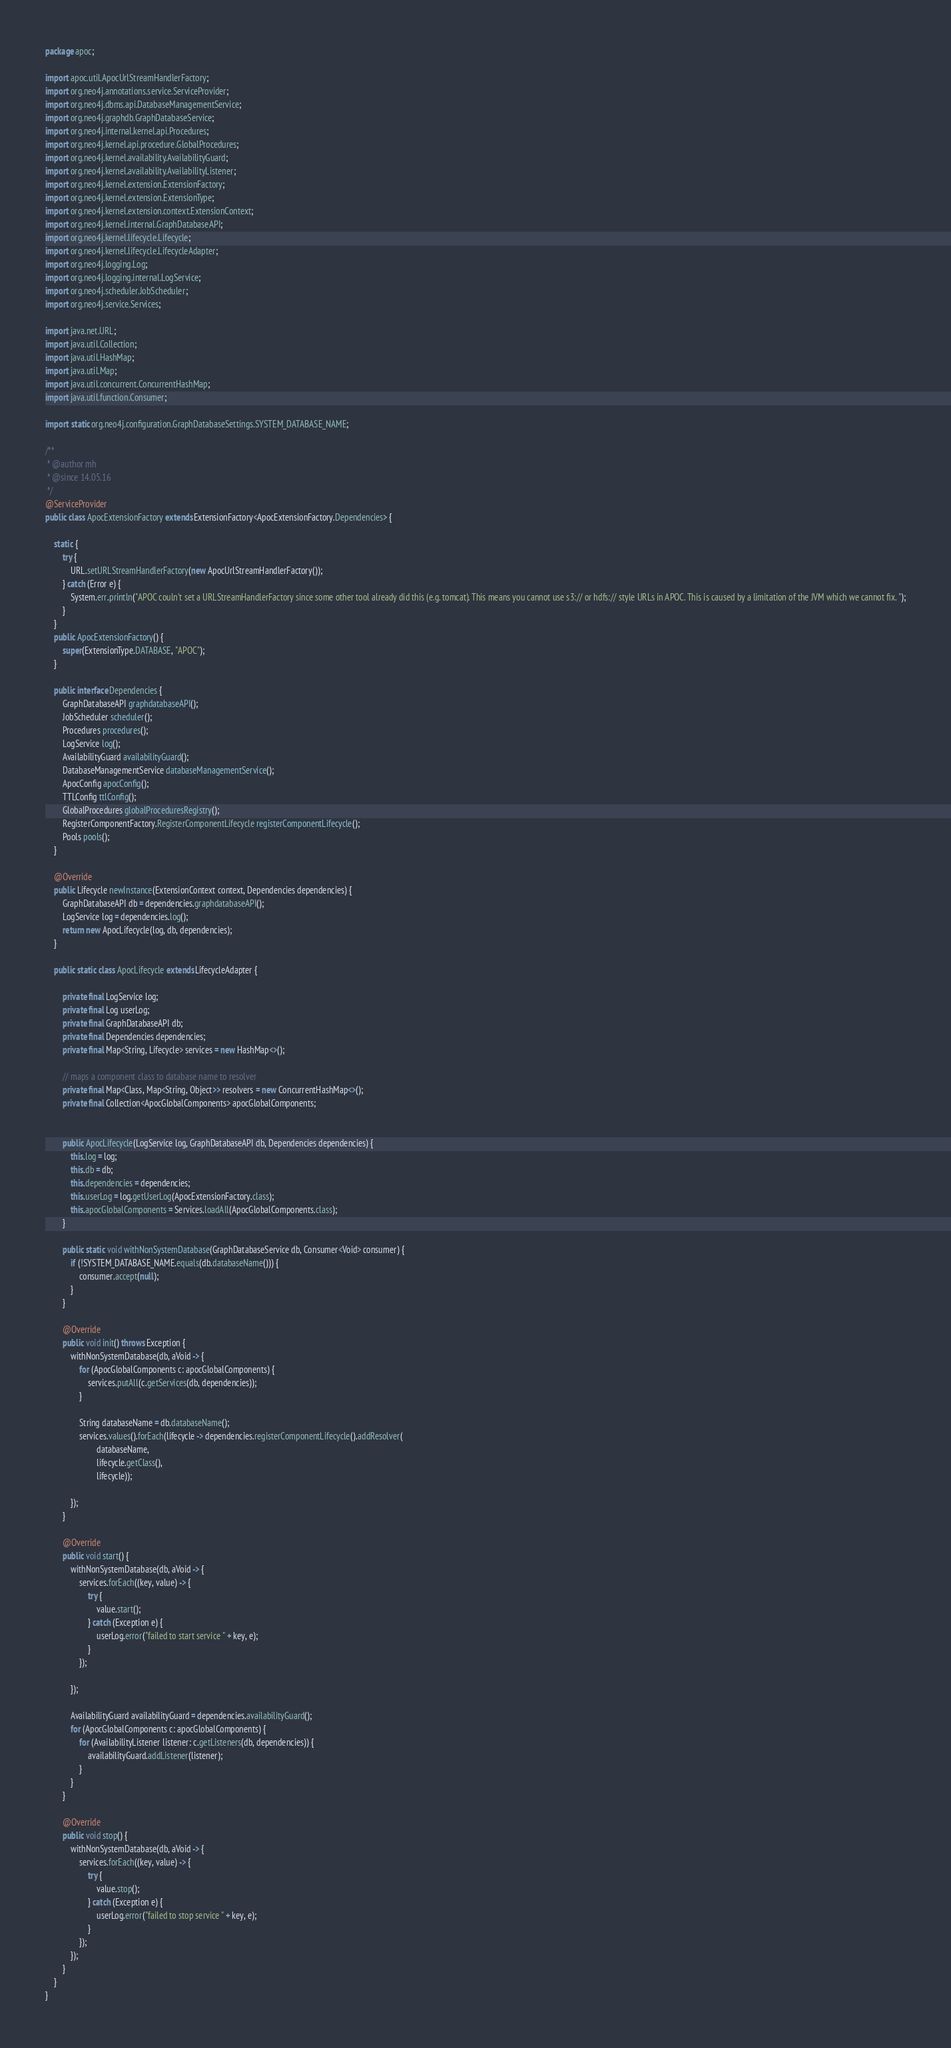Convert code to text. <code><loc_0><loc_0><loc_500><loc_500><_Java_>package apoc;

import apoc.util.ApocUrlStreamHandlerFactory;
import org.neo4j.annotations.service.ServiceProvider;
import org.neo4j.dbms.api.DatabaseManagementService;
import org.neo4j.graphdb.GraphDatabaseService;
import org.neo4j.internal.kernel.api.Procedures;
import org.neo4j.kernel.api.procedure.GlobalProcedures;
import org.neo4j.kernel.availability.AvailabilityGuard;
import org.neo4j.kernel.availability.AvailabilityListener;
import org.neo4j.kernel.extension.ExtensionFactory;
import org.neo4j.kernel.extension.ExtensionType;
import org.neo4j.kernel.extension.context.ExtensionContext;
import org.neo4j.kernel.internal.GraphDatabaseAPI;
import org.neo4j.kernel.lifecycle.Lifecycle;
import org.neo4j.kernel.lifecycle.LifecycleAdapter;
import org.neo4j.logging.Log;
import org.neo4j.logging.internal.LogService;
import org.neo4j.scheduler.JobScheduler;
import org.neo4j.service.Services;

import java.net.URL;
import java.util.Collection;
import java.util.HashMap;
import java.util.Map;
import java.util.concurrent.ConcurrentHashMap;
import java.util.function.Consumer;

import static org.neo4j.configuration.GraphDatabaseSettings.SYSTEM_DATABASE_NAME;

/**
 * @author mh
 * @since 14.05.16
 */
@ServiceProvider
public class ApocExtensionFactory extends ExtensionFactory<ApocExtensionFactory.Dependencies> {

    static {
        try {
            URL.setURLStreamHandlerFactory(new ApocUrlStreamHandlerFactory());
        } catch (Error e) {
            System.err.println("APOC couln't set a URLStreamHandlerFactory since some other tool already did this (e.g. tomcat). This means you cannot use s3:// or hdfs:// style URLs in APOC. This is caused by a limitation of the JVM which we cannot fix. ");
        }
    }
    public ApocExtensionFactory() {
        super(ExtensionType.DATABASE, "APOC");
    }

    public interface Dependencies {
        GraphDatabaseAPI graphdatabaseAPI();
        JobScheduler scheduler();
        Procedures procedures();
        LogService log();
        AvailabilityGuard availabilityGuard();
        DatabaseManagementService databaseManagementService();
        ApocConfig apocConfig();
        TTLConfig ttlConfig();
        GlobalProcedures globalProceduresRegistry();
        RegisterComponentFactory.RegisterComponentLifecycle registerComponentLifecycle();
        Pools pools();
    }

    @Override
    public Lifecycle newInstance(ExtensionContext context, Dependencies dependencies) {
        GraphDatabaseAPI db = dependencies.graphdatabaseAPI();
        LogService log = dependencies.log();
        return new ApocLifecycle(log, db, dependencies);
    }

    public static class ApocLifecycle extends LifecycleAdapter {

        private final LogService log;
        private final Log userLog;
        private final GraphDatabaseAPI db;
        private final Dependencies dependencies;
        private final Map<String, Lifecycle> services = new HashMap<>();

        // maps a component class to database name to resolver
        private final Map<Class, Map<String, Object>> resolvers = new ConcurrentHashMap<>();
        private final Collection<ApocGlobalComponents> apocGlobalComponents;


        public ApocLifecycle(LogService log, GraphDatabaseAPI db, Dependencies dependencies) {
            this.log = log;
            this.db = db;
            this.dependencies = dependencies;
            this.userLog = log.getUserLog(ApocExtensionFactory.class);
            this.apocGlobalComponents = Services.loadAll(ApocGlobalComponents.class);
        }

        public static void withNonSystemDatabase(GraphDatabaseService db, Consumer<Void> consumer) {
            if (!SYSTEM_DATABASE_NAME.equals(db.databaseName())) {
                consumer.accept(null);
            }
        }

        @Override
        public void init() throws Exception {
            withNonSystemDatabase(db, aVoid -> {
                for (ApocGlobalComponents c: apocGlobalComponents) {
                    services.putAll(c.getServices(db, dependencies));
                }

                String databaseName = db.databaseName();
                services.values().forEach(lifecycle -> dependencies.registerComponentLifecycle().addResolver(
                        databaseName,
                        lifecycle.getClass(),
                        lifecycle));

            });
        }

        @Override
        public void start() {
            withNonSystemDatabase(db, aVoid -> {
                services.forEach((key, value) -> {
                    try {
                        value.start();
                    } catch (Exception e) {
                        userLog.error("failed to start service " + key, e);
                    }
                });

            });

            AvailabilityGuard availabilityGuard = dependencies.availabilityGuard();
            for (ApocGlobalComponents c: apocGlobalComponents) {
                for (AvailabilityListener listener: c.getListeners(db, dependencies)) {
                    availabilityGuard.addListener(listener);
                }
            }
        }

        @Override
        public void stop() {
            withNonSystemDatabase(db, aVoid -> {
                services.forEach((key, value) -> {
                    try {
                        value.stop();
                    } catch (Exception e) {
                        userLog.error("failed to stop service " + key, e);
                    }
                });
            });
        }
    }
}
</code> 